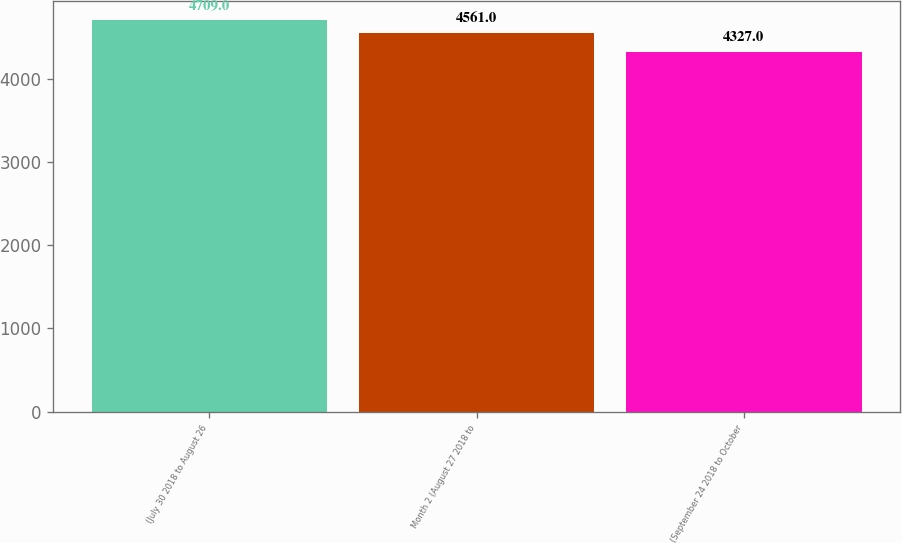Convert chart. <chart><loc_0><loc_0><loc_500><loc_500><bar_chart><fcel>(July 30 2018 to August 26<fcel>Month 2 (August 27 2018 to<fcel>(September 24 2018 to October<nl><fcel>4709<fcel>4561<fcel>4327<nl></chart> 